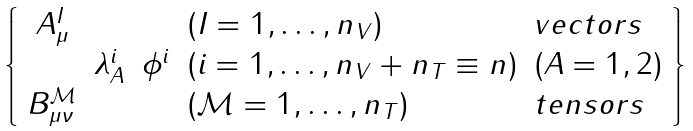<formula> <loc_0><loc_0><loc_500><loc_500>\left \{ \begin{array} { c c c l l } { { A _ { \mu } ^ { I } } } & { \null } & { \null } & { { ( I = 1 , \dots , n _ { V } ) } } & { v e c t o r s } \\ { \null } & { { \lambda _ { A } ^ { i } } } & { { \phi ^ { i } } } & { { ( i = 1 , \dots , n _ { V } + n _ { T } \equiv n ) } } & { ( A = 1 , 2 ) } \\ { { B _ { \mu \nu } ^ { \mathcal { M } } } } & { \null } & { \null } & { { ( \mathcal { M } = 1 , \dots , n _ { T } ) } } & { t e n s o r s \ } \end{array} \right \}</formula> 